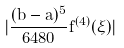Convert formula to latex. <formula><loc_0><loc_0><loc_500><loc_500>| \frac { ( b - a ) ^ { 5 } } { 6 4 8 0 } f ^ { ( 4 ) } ( \xi ) |</formula> 